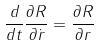Convert formula to latex. <formula><loc_0><loc_0><loc_500><loc_500>\frac { d } { d t } \frac { \partial R } { \partial \dot { r } } = \frac { \partial R } { \partial r }</formula> 